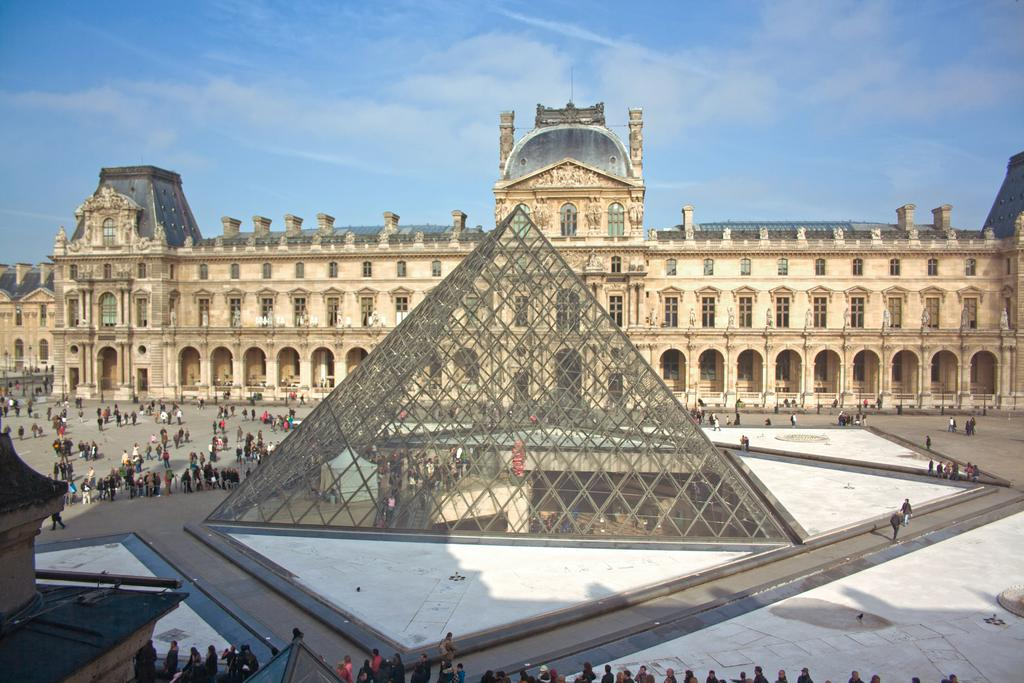What can be seen in the image? There are people standing in the image, along with buildings, windows, clouds, and the sky visible in the background. Can you describe the people in the image? The facts provided do not give specific details about the people, but we know they are present in the image. What type of structures are visible in the image? There are buildings in the image. What is visible in the background of the image? Clouds and the sky are visible in the background of the image. Where is the field located in the image? There is no field present in the image. What type of meeting is taking place in the image? There is no meeting taking place in the image; it simply shows people standing and buildings. 